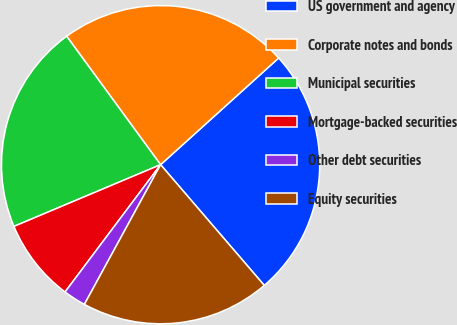<chart> <loc_0><loc_0><loc_500><loc_500><pie_chart><fcel>US government and agency<fcel>Corporate notes and bonds<fcel>Municipal securities<fcel>Mortgage-backed securities<fcel>Other debt securities<fcel>Equity securities<nl><fcel>25.4%<fcel>23.35%<fcel>21.29%<fcel>8.41%<fcel>2.3%<fcel>19.24%<nl></chart> 